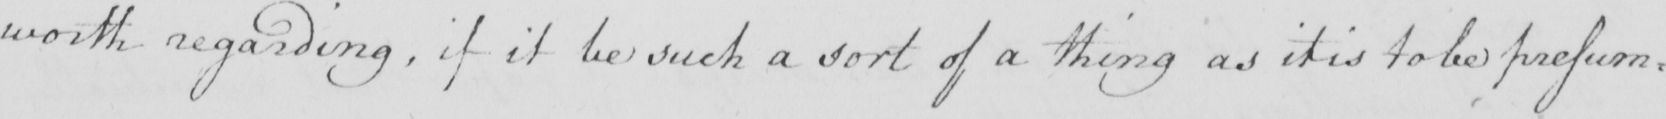What text is written in this handwritten line? worth regarding , if it be such a sort of thing as it is to be presum : 